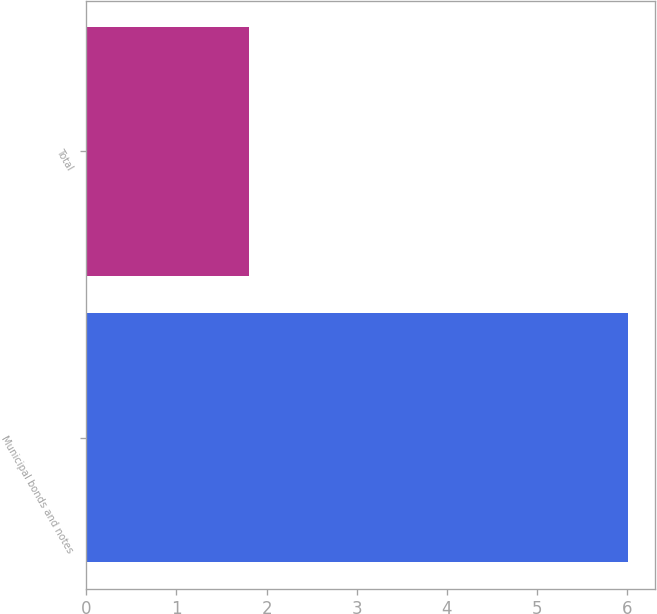Convert chart to OTSL. <chart><loc_0><loc_0><loc_500><loc_500><bar_chart><fcel>Municipal bonds and notes<fcel>Total<nl><fcel>6.01<fcel>1.8<nl></chart> 